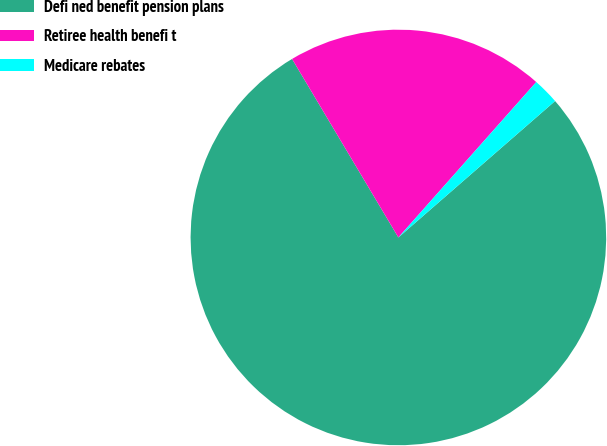Convert chart. <chart><loc_0><loc_0><loc_500><loc_500><pie_chart><fcel>Defi ned benefit pension plans<fcel>Retiree health benefi t<fcel>Medicare rebates<nl><fcel>77.86%<fcel>20.1%<fcel>2.05%<nl></chart> 